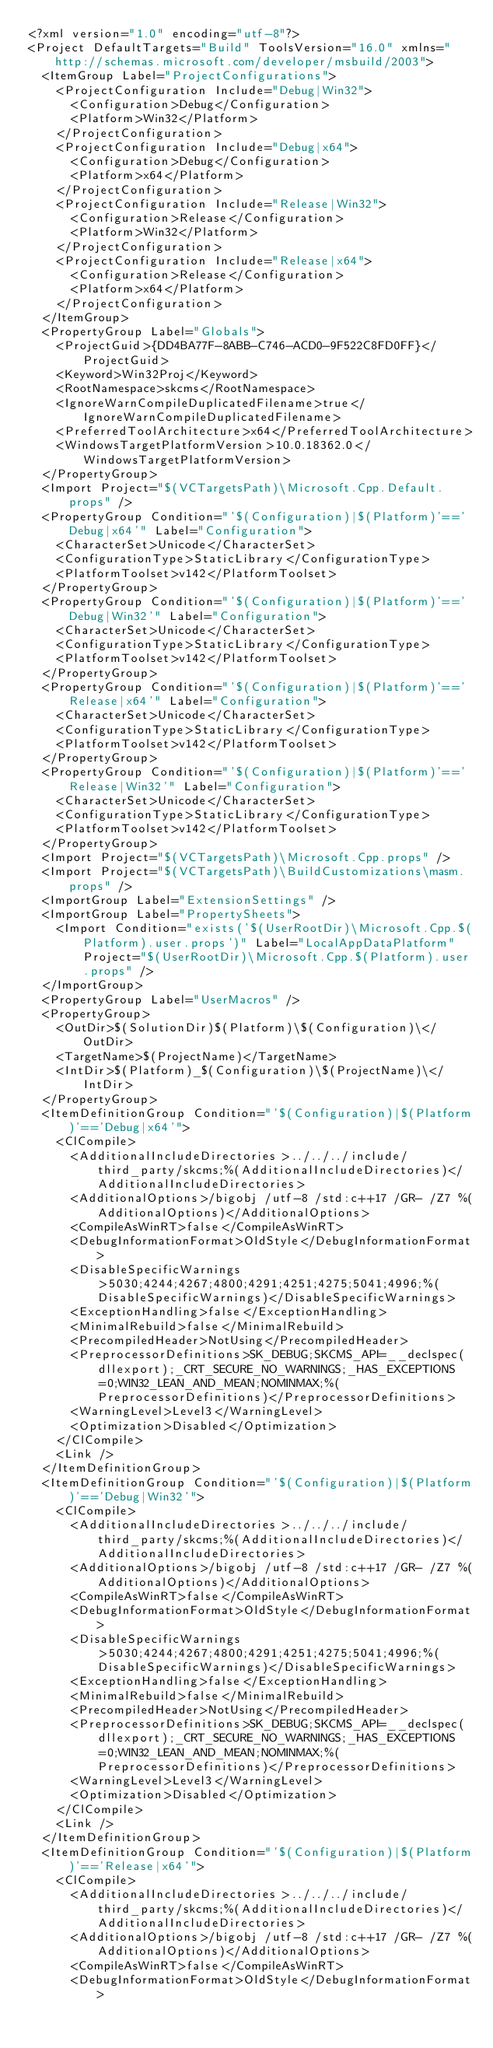<code> <loc_0><loc_0><loc_500><loc_500><_XML_><?xml version="1.0" encoding="utf-8"?>
<Project DefaultTargets="Build" ToolsVersion="16.0" xmlns="http://schemas.microsoft.com/developer/msbuild/2003">
  <ItemGroup Label="ProjectConfigurations">
    <ProjectConfiguration Include="Debug|Win32">
      <Configuration>Debug</Configuration>
      <Platform>Win32</Platform>
    </ProjectConfiguration>
    <ProjectConfiguration Include="Debug|x64">
      <Configuration>Debug</Configuration>
      <Platform>x64</Platform>
    </ProjectConfiguration>
    <ProjectConfiguration Include="Release|Win32">
      <Configuration>Release</Configuration>
      <Platform>Win32</Platform>
    </ProjectConfiguration>
    <ProjectConfiguration Include="Release|x64">
      <Configuration>Release</Configuration>
      <Platform>x64</Platform>
    </ProjectConfiguration>
  </ItemGroup>
  <PropertyGroup Label="Globals">
    <ProjectGuid>{DD4BA77F-8ABB-C746-ACD0-9F522C8FD0FF}</ProjectGuid>
    <Keyword>Win32Proj</Keyword>
    <RootNamespace>skcms</RootNamespace>
    <IgnoreWarnCompileDuplicatedFilename>true</IgnoreWarnCompileDuplicatedFilename>
    <PreferredToolArchitecture>x64</PreferredToolArchitecture>
    <WindowsTargetPlatformVersion>10.0.18362.0</WindowsTargetPlatformVersion>
  </PropertyGroup>
  <Import Project="$(VCTargetsPath)\Microsoft.Cpp.Default.props" />
  <PropertyGroup Condition="'$(Configuration)|$(Platform)'=='Debug|x64'" Label="Configuration">
    <CharacterSet>Unicode</CharacterSet>
    <ConfigurationType>StaticLibrary</ConfigurationType>
    <PlatformToolset>v142</PlatformToolset>
  </PropertyGroup>
  <PropertyGroup Condition="'$(Configuration)|$(Platform)'=='Debug|Win32'" Label="Configuration">
    <CharacterSet>Unicode</CharacterSet>
    <ConfigurationType>StaticLibrary</ConfigurationType>
    <PlatformToolset>v142</PlatformToolset>
  </PropertyGroup>
  <PropertyGroup Condition="'$(Configuration)|$(Platform)'=='Release|x64'" Label="Configuration">
    <CharacterSet>Unicode</CharacterSet>
    <ConfigurationType>StaticLibrary</ConfigurationType>
    <PlatformToolset>v142</PlatformToolset>
  </PropertyGroup>
  <PropertyGroup Condition="'$(Configuration)|$(Platform)'=='Release|Win32'" Label="Configuration">
    <CharacterSet>Unicode</CharacterSet>
    <ConfigurationType>StaticLibrary</ConfigurationType>
    <PlatformToolset>v142</PlatformToolset>
  </PropertyGroup>
  <Import Project="$(VCTargetsPath)\Microsoft.Cpp.props" />
  <Import Project="$(VCTargetsPath)\BuildCustomizations\masm.props" />
  <ImportGroup Label="ExtensionSettings" />
  <ImportGroup Label="PropertySheets">
    <Import Condition="exists('$(UserRootDir)\Microsoft.Cpp.$(Platform).user.props')" Label="LocalAppDataPlatform" Project="$(UserRootDir)\Microsoft.Cpp.$(Platform).user.props" />
  </ImportGroup>
  <PropertyGroup Label="UserMacros" />
  <PropertyGroup>
    <OutDir>$(SolutionDir)$(Platform)\$(Configuration)\</OutDir>
    <TargetName>$(ProjectName)</TargetName>
    <IntDir>$(Platform)_$(Configuration)\$(ProjectName)\</IntDir>
  </PropertyGroup>
  <ItemDefinitionGroup Condition="'$(Configuration)|$(Platform)'=='Debug|x64'">
    <ClCompile>
      <AdditionalIncludeDirectories>../../../include/third_party/skcms;%(AdditionalIncludeDirectories)</AdditionalIncludeDirectories>
      <AdditionalOptions>/bigobj /utf-8 /std:c++17 /GR- /Z7 %(AdditionalOptions)</AdditionalOptions>
      <CompileAsWinRT>false</CompileAsWinRT>
      <DebugInformationFormat>OldStyle</DebugInformationFormat>
      <DisableSpecificWarnings>5030;4244;4267;4800;4291;4251;4275;5041;4996;%(DisableSpecificWarnings)</DisableSpecificWarnings>
      <ExceptionHandling>false</ExceptionHandling>
      <MinimalRebuild>false</MinimalRebuild>
      <PrecompiledHeader>NotUsing</PrecompiledHeader>
      <PreprocessorDefinitions>SK_DEBUG;SKCMS_API=__declspec(dllexport);_CRT_SECURE_NO_WARNINGS;_HAS_EXCEPTIONS=0;WIN32_LEAN_AND_MEAN;NOMINMAX;%(PreprocessorDefinitions)</PreprocessorDefinitions>
      <WarningLevel>Level3</WarningLevel>
      <Optimization>Disabled</Optimization>
    </ClCompile>
    <Link />
  </ItemDefinitionGroup>
  <ItemDefinitionGroup Condition="'$(Configuration)|$(Platform)'=='Debug|Win32'">
    <ClCompile>
      <AdditionalIncludeDirectories>../../../include/third_party/skcms;%(AdditionalIncludeDirectories)</AdditionalIncludeDirectories>
      <AdditionalOptions>/bigobj /utf-8 /std:c++17 /GR- /Z7 %(AdditionalOptions)</AdditionalOptions>
      <CompileAsWinRT>false</CompileAsWinRT>
      <DebugInformationFormat>OldStyle</DebugInformationFormat>
      <DisableSpecificWarnings>5030;4244;4267;4800;4291;4251;4275;5041;4996;%(DisableSpecificWarnings)</DisableSpecificWarnings>
      <ExceptionHandling>false</ExceptionHandling>
      <MinimalRebuild>false</MinimalRebuild>
      <PrecompiledHeader>NotUsing</PrecompiledHeader>
      <PreprocessorDefinitions>SK_DEBUG;SKCMS_API=__declspec(dllexport);_CRT_SECURE_NO_WARNINGS;_HAS_EXCEPTIONS=0;WIN32_LEAN_AND_MEAN;NOMINMAX;%(PreprocessorDefinitions)</PreprocessorDefinitions>
      <WarningLevel>Level3</WarningLevel>
      <Optimization>Disabled</Optimization>
    </ClCompile>
    <Link />
  </ItemDefinitionGroup>
  <ItemDefinitionGroup Condition="'$(Configuration)|$(Platform)'=='Release|x64'">
    <ClCompile>
      <AdditionalIncludeDirectories>../../../include/third_party/skcms;%(AdditionalIncludeDirectories)</AdditionalIncludeDirectories>
      <AdditionalOptions>/bigobj /utf-8 /std:c++17 /GR- /Z7 %(AdditionalOptions)</AdditionalOptions>
      <CompileAsWinRT>false</CompileAsWinRT>
      <DebugInformationFormat>OldStyle</DebugInformationFormat></code> 